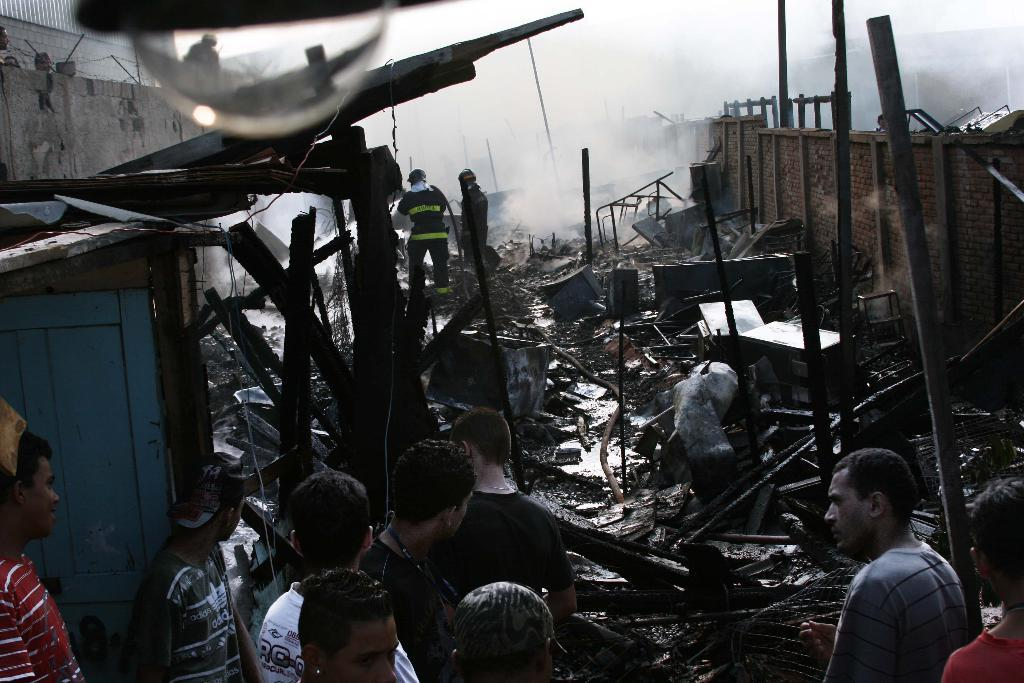What can be seen in the foreground of the image? There are persons standing in the foreground of the image. What is the condition of the objects in the background of the image? There are broken tables and damaged walls in the background of the image. What is the presence of smoke in the image indicative of? The smoke visible in the image suggests that there may have been a fire or some other event causing smoke. What is the source of light at the top of the image? There is a bulb at the top of the image, which is likely the source of light. What type of square is depicted in the image? There is no square present in the image. What emotion is being expressed by the persons in the image? The provided facts do not give any information about the emotions or expressions of the persons in the image. What experience can be gained from observing the damaged walls in the image? The provided facts do not give any information about the experience or lessons that can be learned from observing the damaged walls in the image. 